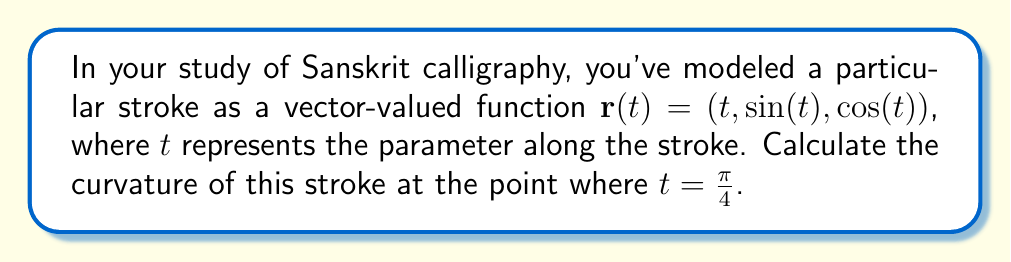Show me your answer to this math problem. To calculate the curvature of the Sanskrit calligraphy stroke, we'll use the formula for the curvature of a vector-valued function:

$$\kappa = \frac{|\mathbf{r}'(t) \times \mathbf{r}''(t)|}{|\mathbf{r}'(t)|^3}$$

Let's proceed step-by-step:

1) First, we need to find $\mathbf{r}'(t)$ and $\mathbf{r}''(t)$:

   $\mathbf{r}'(t) = (1, \cos(t), -\sin(t))$
   $\mathbf{r}''(t) = (0, -\sin(t), -\cos(t))$

2) Now, let's calculate $\mathbf{r}'(t) \times \mathbf{r}''(t)$:

   $$\mathbf{r}'(t) \times \mathbf{r}''(t) = \begin{vmatrix} 
   \mathbf{i} & \mathbf{j} & \mathbf{k} \\
   1 & \cos(t) & -\sin(t) \\
   0 & -\sin(t) & -\cos(t)
   \end{vmatrix}$$

   $= (-\cos^2(t) - \sin^2(t))\mathbf{i} + (-\sin(t))\mathbf{j} + (\cos(t))\mathbf{k}$

   $= (-1)\mathbf{i} + (-\sin(t))\mathbf{j} + (\cos(t))\mathbf{k}$

3) The magnitude of this cross product is:

   $|\mathbf{r}'(t) \times \mathbf{r}''(t)| = \sqrt{1 + \sin^2(t) + \cos^2(t)} = \sqrt{2}$

4) Next, we need to calculate $|\mathbf{r}'(t)|^3$:

   $|\mathbf{r}'(t)| = \sqrt{1 + \cos^2(t) + \sin^2(t)} = \sqrt{2}$

   $|\mathbf{r}'(t)|^3 = (\sqrt{2})^3 = 2\sqrt{2}$

5) Now we can plug these values into our curvature formula:

   $$\kappa = \frac{|\mathbf{r}'(t) \times \mathbf{r}''(t)|}{|\mathbf{r}'(t)|^3} = \frac{\sqrt{2}}{2\sqrt{2}} = \frac{1}{2}$$

6) This result is constant for all $t$, including $t = \frac{\pi}{4}$.

Therefore, the curvature of the Sanskrit calligraphy stroke at $t = \frac{\pi}{4}$ (and indeed at all points) is $\frac{1}{2}$.
Answer: $\frac{1}{2}$ 